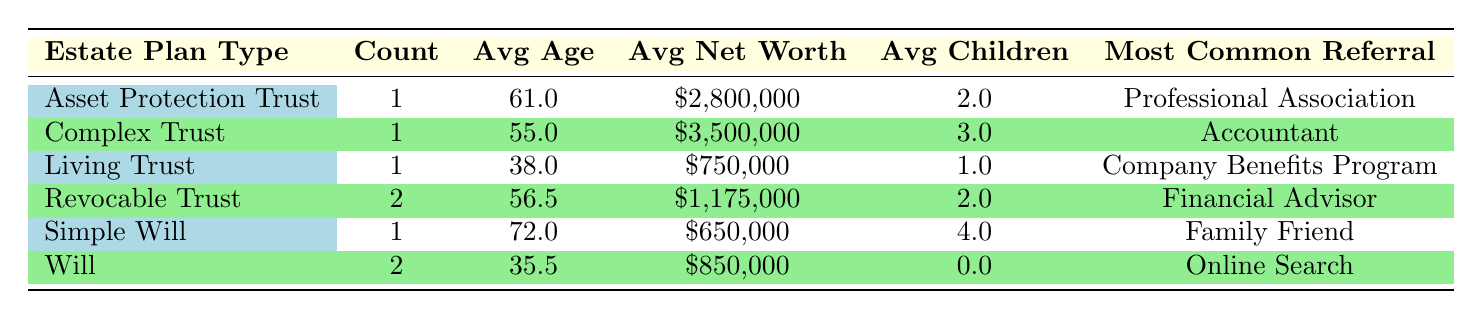What is the total number of clients with a Simple Will? There is 1 client listed under the estate plan type "Simple Will." The Count column indicates the number of clients for that estate plan type.
Answer: 1 What is the average age of clients with a Revocable Trust? The table shows 2 clients with a Revocable Trust. Their ages are 56 and 57. The average is calculated as (56 + 57) / 2 = 56.5.
Answer: 56.5 Is the most common referral source for clients with a Living Trust a Company Benefits Program? The table states that the most common referral for clients with a Living Trust is "Company Benefits Program." This matches the question exactly.
Answer: Yes What is the average net worth of clients with a Will? There are 2 clients listed with a Will. Their net worth values are 1,200,000 and 500,000. To find the average, add these values: 1,200,000 + 500,000 = 1,700,000, then divide by 2, resulting in 850,000.
Answer: 850000 Which estate plan type has the highest average net worth? The highest average net worth can be found by comparing the Avg Net Worth column for each estate plan type. The Complex Trust has an average net worth of 3,500,000, which is higher than any other estate plan type listed in the table.
Answer: Complex Trust How many clients have an Asset Protection Trust, and what is their average age? There is 1 client with an Asset Protection Trust, and their age is 61. Since there's only one client, the average age is also 61.
Answer: 61 Is there a correlation between marital status and estate plan type? Examining the table shows that different estate plan types are associated with different marital statuses, such as Will being used by singles and Simple Will by a widowed client. However, there is a mix without a clear correlation.
Answer: No What is the average number of children among clients with a Will? There are 2 clients with a Will. Their count of children is 0 and 0, which sum to 0. Therefore, the average is 0/2 = 0.
Answer: 0 Which referral source is most common for clients who have a Complex Trust? The table indicates the most common referral source for the only client with a Complex Trust is "Accountant." Since there is only one client, this is definitive.
Answer: Accountant 